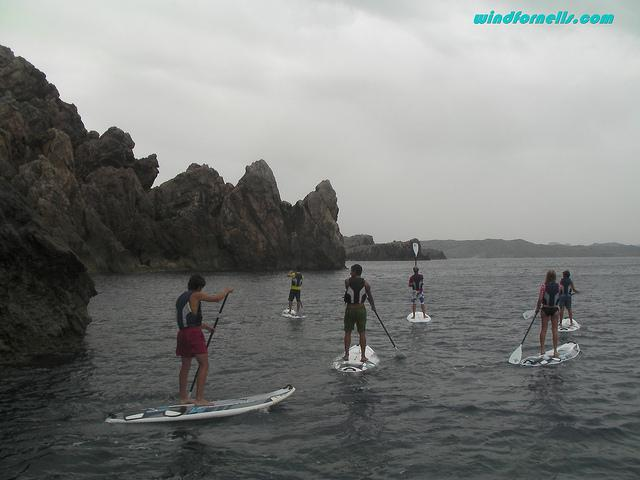What is required for this activity? water 